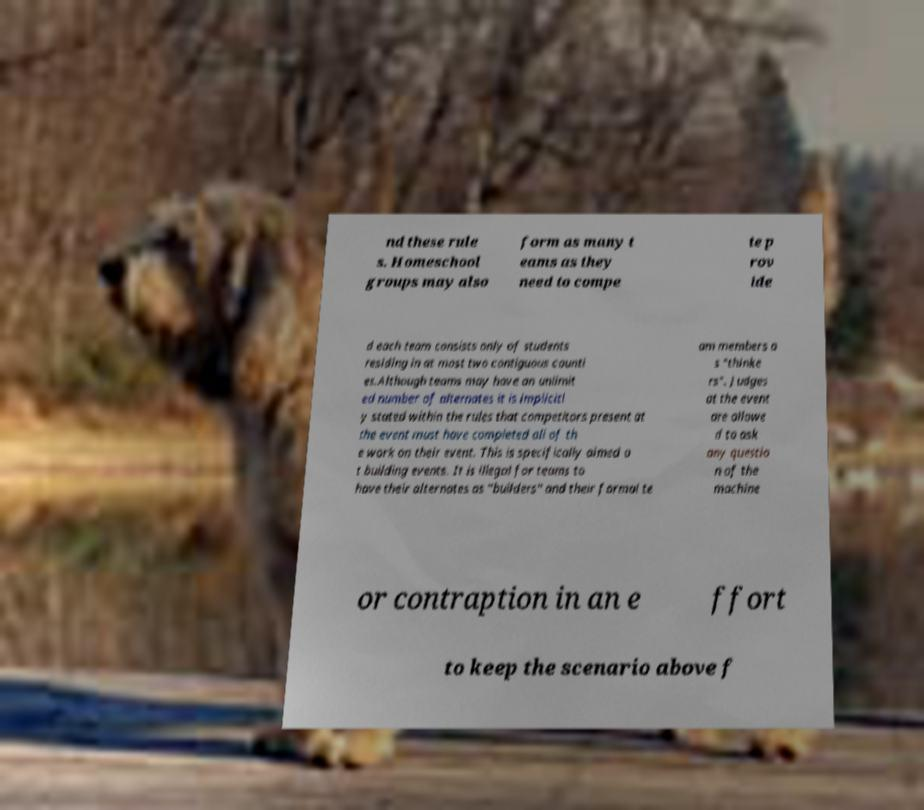Please identify and transcribe the text found in this image. nd these rule s. Homeschool groups may also form as many t eams as they need to compe te p rov ide d each team consists only of students residing in at most two contiguous counti es.Although teams may have an unlimit ed number of alternates it is implicitl y stated within the rules that competitors present at the event must have completed all of th e work on their event. This is specifically aimed a t building events. It is illegal for teams to have their alternates as "builders" and their formal te am members a s "thinke rs". Judges at the event are allowe d to ask any questio n of the machine or contraption in an e ffort to keep the scenario above f 